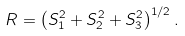<formula> <loc_0><loc_0><loc_500><loc_500>R = \left ( S _ { 1 } ^ { 2 } + S _ { 2 } ^ { 2 } + S _ { 3 } ^ { 2 } \right ) ^ { 1 / 2 } .</formula> 